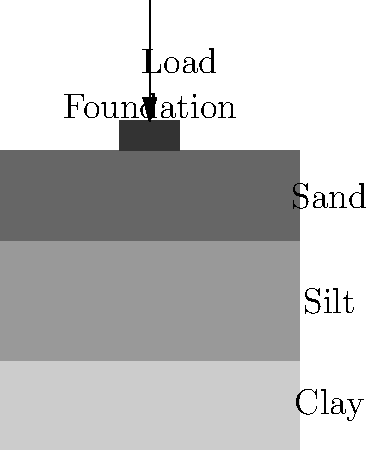Based on the soil profile and foundation shown in the diagram, what is the primary factor that will determine the settlement of the foundation under the applied load? To understand the primary factor determining foundation settlement, let's break down the problem:

1. Soil Profile:
   - The diagram shows three distinct soil layers: clay (bottom), silt (middle), and sand (top).
   - Each soil type has different properties that affect settlement.

2. Foundation:
   - A shallow foundation is shown at the top of the soil profile.
   - It's subjected to a vertical load.

3. Settlement Factors:
   - Clay: Known for high compressibility and slow consolidation.
   - Silt: Moderate compressibility.
   - Sand: Generally less compressible than clay or silt.

4. Primary Settlement Consideration:
   - In layered soil profiles, the most compressible layer typically dominates settlement behavior.
   - Clay, being at the bottom and most compressible, will likely contribute most to long-term settlement.

5. Time Factor:
   - Clay undergoes consolidation settlement over time, which is often the largest component of total settlement.

6. Load Distribution:
   - The load spreads with depth, affecting deeper layers significantly.

7. Project Sponsor Perspective:
   - For a sponsor focused on results, the key concern is the potential for ongoing, long-term settlement that could affect the structure's performance and stability over time.

Given these factors, the primary determinant of settlement in this case is the properties of the clay layer, particularly its consolidation characteristics.
Answer: Clay layer's consolidation properties 